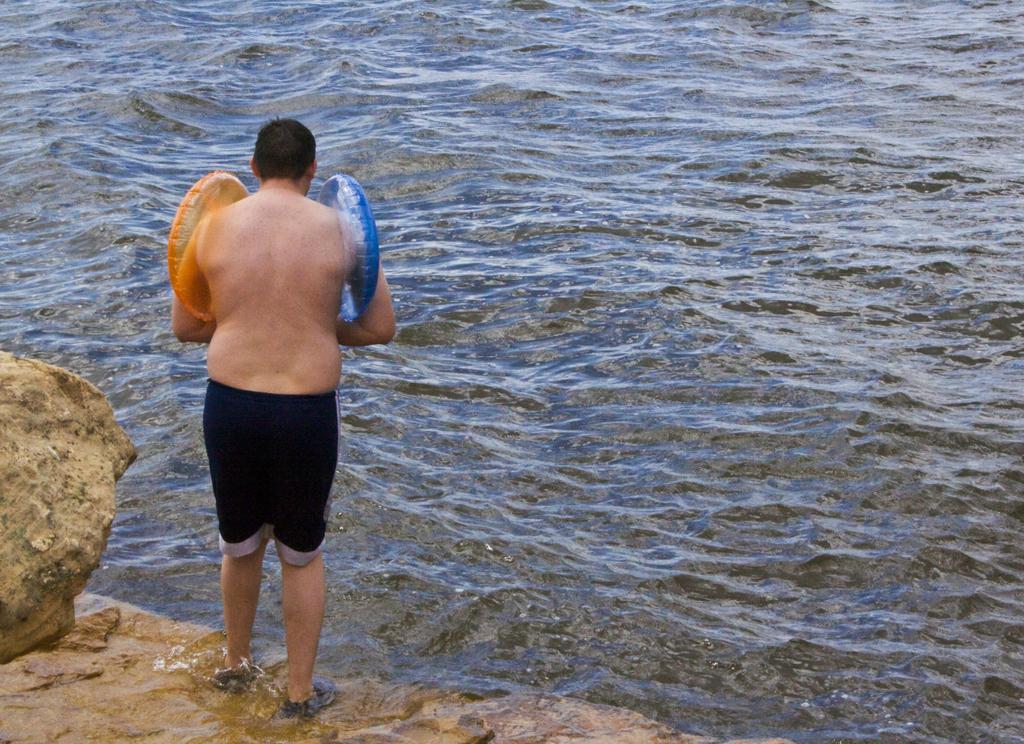How would you summarize this image in a sentence or two? In this image I see a man who is wearing black shorts and I see that he is wearing rubber tubes which are of orange and blue in color and I see the rocks. In the background I see the water. 